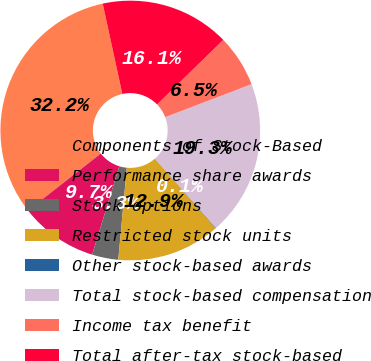Convert chart. <chart><loc_0><loc_0><loc_500><loc_500><pie_chart><fcel>Components of Stock-Based<fcel>Performance share awards<fcel>Stock options<fcel>Restricted stock units<fcel>Other stock-based awards<fcel>Total stock-based compensation<fcel>Income tax benefit<fcel>Total after-tax stock-based<nl><fcel>32.16%<fcel>9.69%<fcel>3.27%<fcel>12.9%<fcel>0.06%<fcel>19.32%<fcel>6.48%<fcel>16.11%<nl></chart> 